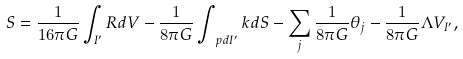Convert formula to latex. <formula><loc_0><loc_0><loc_500><loc_500>S = \frac { 1 } { 1 6 \pi G } \int _ { I ^ { \prime } } R d V - \frac { 1 } { 8 \pi G } \int _ { \ p d I ^ { \prime } } k d S - \sum _ { j } \frac { 1 } { 8 \pi G } \theta _ { j } - \frac { 1 } { 8 \pi G } \Lambda V _ { I ^ { \prime } } ,</formula> 